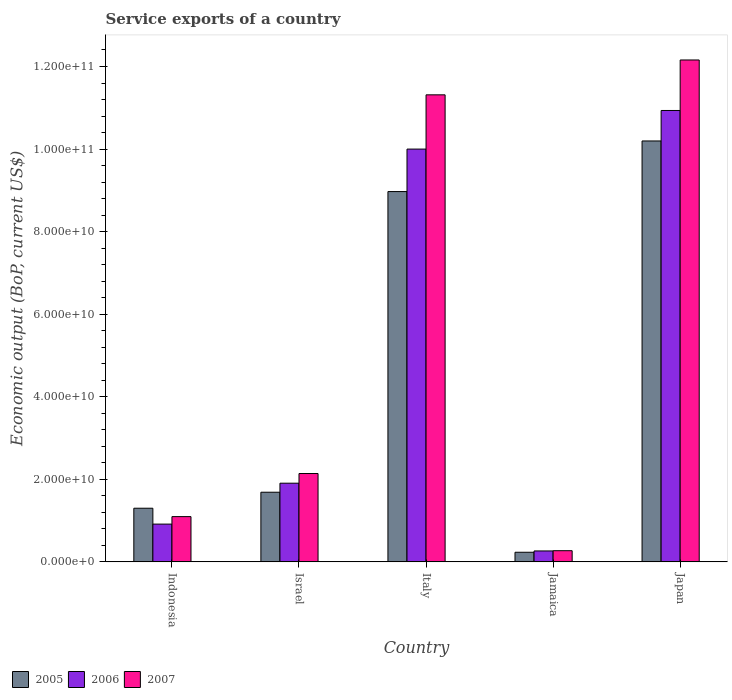How many different coloured bars are there?
Make the answer very short. 3. How many groups of bars are there?
Keep it short and to the point. 5. Are the number of bars per tick equal to the number of legend labels?
Your answer should be very brief. Yes. Are the number of bars on each tick of the X-axis equal?
Offer a very short reply. Yes. How many bars are there on the 4th tick from the right?
Provide a succinct answer. 3. What is the label of the 4th group of bars from the left?
Make the answer very short. Jamaica. What is the service exports in 2005 in Japan?
Offer a terse response. 1.02e+11. Across all countries, what is the maximum service exports in 2005?
Offer a very short reply. 1.02e+11. Across all countries, what is the minimum service exports in 2007?
Give a very brief answer. 2.71e+09. In which country was the service exports in 2006 maximum?
Offer a terse response. Japan. In which country was the service exports in 2006 minimum?
Provide a short and direct response. Jamaica. What is the total service exports in 2005 in the graph?
Ensure brevity in your answer.  2.24e+11. What is the difference between the service exports in 2007 in Israel and that in Italy?
Give a very brief answer. -9.17e+1. What is the difference between the service exports in 2007 in Israel and the service exports in 2006 in Indonesia?
Your response must be concise. 1.23e+1. What is the average service exports in 2006 per country?
Offer a terse response. 4.80e+1. What is the difference between the service exports of/in 2005 and service exports of/in 2006 in Jamaica?
Offer a very short reply. -3.19e+08. What is the ratio of the service exports in 2005 in Italy to that in Japan?
Your answer should be compact. 0.88. Is the service exports in 2006 in Italy less than that in Jamaica?
Ensure brevity in your answer.  No. Is the difference between the service exports in 2005 in Indonesia and Jamaica greater than the difference between the service exports in 2006 in Indonesia and Jamaica?
Offer a terse response. Yes. What is the difference between the highest and the second highest service exports in 2007?
Offer a very short reply. 1.00e+11. What is the difference between the highest and the lowest service exports in 2006?
Offer a very short reply. 1.07e+11. In how many countries, is the service exports in 2005 greater than the average service exports in 2005 taken over all countries?
Give a very brief answer. 2. How many bars are there?
Offer a terse response. 15. How many countries are there in the graph?
Provide a succinct answer. 5. Does the graph contain any zero values?
Give a very brief answer. No. Does the graph contain grids?
Keep it short and to the point. No. Where does the legend appear in the graph?
Your answer should be very brief. Bottom left. How are the legend labels stacked?
Your response must be concise. Horizontal. What is the title of the graph?
Offer a terse response. Service exports of a country. What is the label or title of the Y-axis?
Offer a terse response. Economic output (BoP, current US$). What is the Economic output (BoP, current US$) in 2005 in Indonesia?
Your response must be concise. 1.30e+1. What is the Economic output (BoP, current US$) in 2006 in Indonesia?
Offer a terse response. 9.15e+09. What is the Economic output (BoP, current US$) of 2007 in Indonesia?
Offer a very short reply. 1.10e+1. What is the Economic output (BoP, current US$) of 2005 in Israel?
Ensure brevity in your answer.  1.69e+1. What is the Economic output (BoP, current US$) in 2006 in Israel?
Make the answer very short. 1.91e+1. What is the Economic output (BoP, current US$) in 2007 in Israel?
Provide a short and direct response. 2.14e+1. What is the Economic output (BoP, current US$) of 2005 in Italy?
Provide a succinct answer. 8.97e+1. What is the Economic output (BoP, current US$) of 2006 in Italy?
Provide a succinct answer. 1.00e+11. What is the Economic output (BoP, current US$) in 2007 in Italy?
Offer a very short reply. 1.13e+11. What is the Economic output (BoP, current US$) of 2005 in Jamaica?
Offer a terse response. 2.33e+09. What is the Economic output (BoP, current US$) of 2006 in Jamaica?
Your answer should be compact. 2.65e+09. What is the Economic output (BoP, current US$) of 2007 in Jamaica?
Give a very brief answer. 2.71e+09. What is the Economic output (BoP, current US$) of 2005 in Japan?
Give a very brief answer. 1.02e+11. What is the Economic output (BoP, current US$) in 2006 in Japan?
Offer a terse response. 1.09e+11. What is the Economic output (BoP, current US$) of 2007 in Japan?
Offer a very short reply. 1.22e+11. Across all countries, what is the maximum Economic output (BoP, current US$) in 2005?
Offer a terse response. 1.02e+11. Across all countries, what is the maximum Economic output (BoP, current US$) of 2006?
Your answer should be compact. 1.09e+11. Across all countries, what is the maximum Economic output (BoP, current US$) in 2007?
Your answer should be very brief. 1.22e+11. Across all countries, what is the minimum Economic output (BoP, current US$) of 2005?
Your answer should be very brief. 2.33e+09. Across all countries, what is the minimum Economic output (BoP, current US$) in 2006?
Ensure brevity in your answer.  2.65e+09. Across all countries, what is the minimum Economic output (BoP, current US$) of 2007?
Ensure brevity in your answer.  2.71e+09. What is the total Economic output (BoP, current US$) in 2005 in the graph?
Provide a succinct answer. 2.24e+11. What is the total Economic output (BoP, current US$) of 2006 in the graph?
Your answer should be compact. 2.40e+11. What is the total Economic output (BoP, current US$) of 2007 in the graph?
Your answer should be very brief. 2.70e+11. What is the difference between the Economic output (BoP, current US$) of 2005 in Indonesia and that in Israel?
Make the answer very short. -3.88e+09. What is the difference between the Economic output (BoP, current US$) in 2006 in Indonesia and that in Israel?
Your response must be concise. -9.91e+09. What is the difference between the Economic output (BoP, current US$) of 2007 in Indonesia and that in Israel?
Your response must be concise. -1.04e+1. What is the difference between the Economic output (BoP, current US$) in 2005 in Indonesia and that in Italy?
Your answer should be very brief. -7.67e+1. What is the difference between the Economic output (BoP, current US$) of 2006 in Indonesia and that in Italy?
Offer a terse response. -9.08e+1. What is the difference between the Economic output (BoP, current US$) of 2007 in Indonesia and that in Italy?
Provide a succinct answer. -1.02e+11. What is the difference between the Economic output (BoP, current US$) in 2005 in Indonesia and that in Jamaica?
Make the answer very short. 1.07e+1. What is the difference between the Economic output (BoP, current US$) of 2006 in Indonesia and that in Jamaica?
Give a very brief answer. 6.50e+09. What is the difference between the Economic output (BoP, current US$) of 2007 in Indonesia and that in Jamaica?
Keep it short and to the point. 8.26e+09. What is the difference between the Economic output (BoP, current US$) of 2005 in Indonesia and that in Japan?
Offer a terse response. -8.90e+1. What is the difference between the Economic output (BoP, current US$) of 2006 in Indonesia and that in Japan?
Give a very brief answer. -1.00e+11. What is the difference between the Economic output (BoP, current US$) of 2007 in Indonesia and that in Japan?
Give a very brief answer. -1.11e+11. What is the difference between the Economic output (BoP, current US$) of 2005 in Israel and that in Italy?
Give a very brief answer. -7.28e+1. What is the difference between the Economic output (BoP, current US$) of 2006 in Israel and that in Italy?
Offer a very short reply. -8.09e+1. What is the difference between the Economic output (BoP, current US$) in 2007 in Israel and that in Italy?
Offer a terse response. -9.17e+1. What is the difference between the Economic output (BoP, current US$) of 2005 in Israel and that in Jamaica?
Provide a short and direct response. 1.45e+1. What is the difference between the Economic output (BoP, current US$) of 2006 in Israel and that in Jamaica?
Keep it short and to the point. 1.64e+1. What is the difference between the Economic output (BoP, current US$) in 2007 in Israel and that in Jamaica?
Provide a short and direct response. 1.87e+1. What is the difference between the Economic output (BoP, current US$) in 2005 in Israel and that in Japan?
Offer a terse response. -8.51e+1. What is the difference between the Economic output (BoP, current US$) in 2006 in Israel and that in Japan?
Keep it short and to the point. -9.03e+1. What is the difference between the Economic output (BoP, current US$) in 2007 in Israel and that in Japan?
Your answer should be very brief. -1.00e+11. What is the difference between the Economic output (BoP, current US$) in 2005 in Italy and that in Jamaica?
Keep it short and to the point. 8.74e+1. What is the difference between the Economic output (BoP, current US$) in 2006 in Italy and that in Jamaica?
Give a very brief answer. 9.73e+1. What is the difference between the Economic output (BoP, current US$) of 2007 in Italy and that in Jamaica?
Your answer should be compact. 1.10e+11. What is the difference between the Economic output (BoP, current US$) of 2005 in Italy and that in Japan?
Your answer should be compact. -1.23e+1. What is the difference between the Economic output (BoP, current US$) of 2006 in Italy and that in Japan?
Keep it short and to the point. -9.36e+09. What is the difference between the Economic output (BoP, current US$) of 2007 in Italy and that in Japan?
Offer a terse response. -8.44e+09. What is the difference between the Economic output (BoP, current US$) of 2005 in Jamaica and that in Japan?
Make the answer very short. -9.96e+1. What is the difference between the Economic output (BoP, current US$) of 2006 in Jamaica and that in Japan?
Provide a succinct answer. -1.07e+11. What is the difference between the Economic output (BoP, current US$) of 2007 in Jamaica and that in Japan?
Your answer should be compact. -1.19e+11. What is the difference between the Economic output (BoP, current US$) of 2005 in Indonesia and the Economic output (BoP, current US$) of 2006 in Israel?
Provide a short and direct response. -6.06e+09. What is the difference between the Economic output (BoP, current US$) in 2005 in Indonesia and the Economic output (BoP, current US$) in 2007 in Israel?
Provide a short and direct response. -8.41e+09. What is the difference between the Economic output (BoP, current US$) in 2006 in Indonesia and the Economic output (BoP, current US$) in 2007 in Israel?
Your response must be concise. -1.23e+1. What is the difference between the Economic output (BoP, current US$) of 2005 in Indonesia and the Economic output (BoP, current US$) of 2006 in Italy?
Provide a short and direct response. -8.70e+1. What is the difference between the Economic output (BoP, current US$) of 2005 in Indonesia and the Economic output (BoP, current US$) of 2007 in Italy?
Make the answer very short. -1.00e+11. What is the difference between the Economic output (BoP, current US$) of 2006 in Indonesia and the Economic output (BoP, current US$) of 2007 in Italy?
Offer a very short reply. -1.04e+11. What is the difference between the Economic output (BoP, current US$) of 2005 in Indonesia and the Economic output (BoP, current US$) of 2006 in Jamaica?
Keep it short and to the point. 1.03e+1. What is the difference between the Economic output (BoP, current US$) in 2005 in Indonesia and the Economic output (BoP, current US$) in 2007 in Jamaica?
Provide a succinct answer. 1.03e+1. What is the difference between the Economic output (BoP, current US$) of 2006 in Indonesia and the Economic output (BoP, current US$) of 2007 in Jamaica?
Make the answer very short. 6.44e+09. What is the difference between the Economic output (BoP, current US$) in 2005 in Indonesia and the Economic output (BoP, current US$) in 2006 in Japan?
Make the answer very short. -9.63e+1. What is the difference between the Economic output (BoP, current US$) in 2005 in Indonesia and the Economic output (BoP, current US$) in 2007 in Japan?
Your answer should be very brief. -1.09e+11. What is the difference between the Economic output (BoP, current US$) of 2006 in Indonesia and the Economic output (BoP, current US$) of 2007 in Japan?
Ensure brevity in your answer.  -1.12e+11. What is the difference between the Economic output (BoP, current US$) of 2005 in Israel and the Economic output (BoP, current US$) of 2006 in Italy?
Offer a very short reply. -8.31e+1. What is the difference between the Economic output (BoP, current US$) of 2005 in Israel and the Economic output (BoP, current US$) of 2007 in Italy?
Provide a short and direct response. -9.63e+1. What is the difference between the Economic output (BoP, current US$) of 2006 in Israel and the Economic output (BoP, current US$) of 2007 in Italy?
Your answer should be very brief. -9.41e+1. What is the difference between the Economic output (BoP, current US$) of 2005 in Israel and the Economic output (BoP, current US$) of 2006 in Jamaica?
Make the answer very short. 1.42e+1. What is the difference between the Economic output (BoP, current US$) of 2005 in Israel and the Economic output (BoP, current US$) of 2007 in Jamaica?
Offer a very short reply. 1.42e+1. What is the difference between the Economic output (BoP, current US$) of 2006 in Israel and the Economic output (BoP, current US$) of 2007 in Jamaica?
Your answer should be compact. 1.64e+1. What is the difference between the Economic output (BoP, current US$) in 2005 in Israel and the Economic output (BoP, current US$) in 2006 in Japan?
Make the answer very short. -9.25e+1. What is the difference between the Economic output (BoP, current US$) of 2005 in Israel and the Economic output (BoP, current US$) of 2007 in Japan?
Keep it short and to the point. -1.05e+11. What is the difference between the Economic output (BoP, current US$) of 2006 in Israel and the Economic output (BoP, current US$) of 2007 in Japan?
Provide a short and direct response. -1.03e+11. What is the difference between the Economic output (BoP, current US$) of 2005 in Italy and the Economic output (BoP, current US$) of 2006 in Jamaica?
Your answer should be compact. 8.71e+1. What is the difference between the Economic output (BoP, current US$) of 2005 in Italy and the Economic output (BoP, current US$) of 2007 in Jamaica?
Make the answer very short. 8.70e+1. What is the difference between the Economic output (BoP, current US$) in 2006 in Italy and the Economic output (BoP, current US$) in 2007 in Jamaica?
Your answer should be very brief. 9.73e+1. What is the difference between the Economic output (BoP, current US$) of 2005 in Italy and the Economic output (BoP, current US$) of 2006 in Japan?
Provide a short and direct response. -1.96e+1. What is the difference between the Economic output (BoP, current US$) in 2005 in Italy and the Economic output (BoP, current US$) in 2007 in Japan?
Keep it short and to the point. -3.19e+1. What is the difference between the Economic output (BoP, current US$) in 2006 in Italy and the Economic output (BoP, current US$) in 2007 in Japan?
Provide a short and direct response. -2.16e+1. What is the difference between the Economic output (BoP, current US$) in 2005 in Jamaica and the Economic output (BoP, current US$) in 2006 in Japan?
Make the answer very short. -1.07e+11. What is the difference between the Economic output (BoP, current US$) of 2005 in Jamaica and the Economic output (BoP, current US$) of 2007 in Japan?
Your answer should be compact. -1.19e+11. What is the difference between the Economic output (BoP, current US$) of 2006 in Jamaica and the Economic output (BoP, current US$) of 2007 in Japan?
Offer a terse response. -1.19e+11. What is the average Economic output (BoP, current US$) in 2005 per country?
Provide a succinct answer. 4.48e+1. What is the average Economic output (BoP, current US$) of 2006 per country?
Ensure brevity in your answer.  4.80e+1. What is the average Economic output (BoP, current US$) in 2007 per country?
Provide a succinct answer. 5.40e+1. What is the difference between the Economic output (BoP, current US$) of 2005 and Economic output (BoP, current US$) of 2006 in Indonesia?
Your response must be concise. 3.85e+09. What is the difference between the Economic output (BoP, current US$) in 2005 and Economic output (BoP, current US$) in 2007 in Indonesia?
Your response must be concise. 2.03e+09. What is the difference between the Economic output (BoP, current US$) in 2006 and Economic output (BoP, current US$) in 2007 in Indonesia?
Make the answer very short. -1.82e+09. What is the difference between the Economic output (BoP, current US$) in 2005 and Economic output (BoP, current US$) in 2006 in Israel?
Provide a succinct answer. -2.19e+09. What is the difference between the Economic output (BoP, current US$) in 2005 and Economic output (BoP, current US$) in 2007 in Israel?
Give a very brief answer. -4.53e+09. What is the difference between the Economic output (BoP, current US$) in 2006 and Economic output (BoP, current US$) in 2007 in Israel?
Keep it short and to the point. -2.34e+09. What is the difference between the Economic output (BoP, current US$) of 2005 and Economic output (BoP, current US$) of 2006 in Italy?
Provide a short and direct response. -1.03e+1. What is the difference between the Economic output (BoP, current US$) in 2005 and Economic output (BoP, current US$) in 2007 in Italy?
Your response must be concise. -2.34e+1. What is the difference between the Economic output (BoP, current US$) of 2006 and Economic output (BoP, current US$) of 2007 in Italy?
Offer a terse response. -1.31e+1. What is the difference between the Economic output (BoP, current US$) in 2005 and Economic output (BoP, current US$) in 2006 in Jamaica?
Offer a terse response. -3.19e+08. What is the difference between the Economic output (BoP, current US$) in 2005 and Economic output (BoP, current US$) in 2007 in Jamaica?
Your answer should be very brief. -3.77e+08. What is the difference between the Economic output (BoP, current US$) of 2006 and Economic output (BoP, current US$) of 2007 in Jamaica?
Offer a terse response. -5.79e+07. What is the difference between the Economic output (BoP, current US$) in 2005 and Economic output (BoP, current US$) in 2006 in Japan?
Keep it short and to the point. -7.38e+09. What is the difference between the Economic output (BoP, current US$) of 2005 and Economic output (BoP, current US$) of 2007 in Japan?
Your response must be concise. -1.96e+1. What is the difference between the Economic output (BoP, current US$) of 2006 and Economic output (BoP, current US$) of 2007 in Japan?
Your answer should be very brief. -1.22e+1. What is the ratio of the Economic output (BoP, current US$) in 2005 in Indonesia to that in Israel?
Make the answer very short. 0.77. What is the ratio of the Economic output (BoP, current US$) in 2006 in Indonesia to that in Israel?
Your answer should be very brief. 0.48. What is the ratio of the Economic output (BoP, current US$) in 2007 in Indonesia to that in Israel?
Offer a very short reply. 0.51. What is the ratio of the Economic output (BoP, current US$) of 2005 in Indonesia to that in Italy?
Ensure brevity in your answer.  0.14. What is the ratio of the Economic output (BoP, current US$) in 2006 in Indonesia to that in Italy?
Your answer should be very brief. 0.09. What is the ratio of the Economic output (BoP, current US$) in 2007 in Indonesia to that in Italy?
Your answer should be compact. 0.1. What is the ratio of the Economic output (BoP, current US$) in 2005 in Indonesia to that in Jamaica?
Give a very brief answer. 5.58. What is the ratio of the Economic output (BoP, current US$) of 2006 in Indonesia to that in Jamaica?
Your answer should be compact. 3.45. What is the ratio of the Economic output (BoP, current US$) in 2007 in Indonesia to that in Jamaica?
Ensure brevity in your answer.  4.05. What is the ratio of the Economic output (BoP, current US$) of 2005 in Indonesia to that in Japan?
Your response must be concise. 0.13. What is the ratio of the Economic output (BoP, current US$) in 2006 in Indonesia to that in Japan?
Make the answer very short. 0.08. What is the ratio of the Economic output (BoP, current US$) of 2007 in Indonesia to that in Japan?
Your answer should be compact. 0.09. What is the ratio of the Economic output (BoP, current US$) in 2005 in Israel to that in Italy?
Give a very brief answer. 0.19. What is the ratio of the Economic output (BoP, current US$) in 2006 in Israel to that in Italy?
Offer a terse response. 0.19. What is the ratio of the Economic output (BoP, current US$) in 2007 in Israel to that in Italy?
Offer a terse response. 0.19. What is the ratio of the Economic output (BoP, current US$) of 2005 in Israel to that in Jamaica?
Ensure brevity in your answer.  7.24. What is the ratio of the Economic output (BoP, current US$) of 2006 in Israel to that in Jamaica?
Ensure brevity in your answer.  7.2. What is the ratio of the Economic output (BoP, current US$) in 2007 in Israel to that in Jamaica?
Ensure brevity in your answer.  7.91. What is the ratio of the Economic output (BoP, current US$) of 2005 in Israel to that in Japan?
Give a very brief answer. 0.17. What is the ratio of the Economic output (BoP, current US$) of 2006 in Israel to that in Japan?
Keep it short and to the point. 0.17. What is the ratio of the Economic output (BoP, current US$) in 2007 in Israel to that in Japan?
Provide a succinct answer. 0.18. What is the ratio of the Economic output (BoP, current US$) of 2005 in Italy to that in Jamaica?
Make the answer very short. 38.5. What is the ratio of the Economic output (BoP, current US$) of 2006 in Italy to that in Jamaica?
Offer a very short reply. 37.75. What is the ratio of the Economic output (BoP, current US$) of 2007 in Italy to that in Jamaica?
Your answer should be very brief. 41.8. What is the ratio of the Economic output (BoP, current US$) of 2005 in Italy to that in Japan?
Your response must be concise. 0.88. What is the ratio of the Economic output (BoP, current US$) of 2006 in Italy to that in Japan?
Make the answer very short. 0.91. What is the ratio of the Economic output (BoP, current US$) in 2007 in Italy to that in Japan?
Provide a short and direct response. 0.93. What is the ratio of the Economic output (BoP, current US$) of 2005 in Jamaica to that in Japan?
Your answer should be compact. 0.02. What is the ratio of the Economic output (BoP, current US$) of 2006 in Jamaica to that in Japan?
Provide a short and direct response. 0.02. What is the ratio of the Economic output (BoP, current US$) in 2007 in Jamaica to that in Japan?
Offer a terse response. 0.02. What is the difference between the highest and the second highest Economic output (BoP, current US$) of 2005?
Ensure brevity in your answer.  1.23e+1. What is the difference between the highest and the second highest Economic output (BoP, current US$) in 2006?
Ensure brevity in your answer.  9.36e+09. What is the difference between the highest and the second highest Economic output (BoP, current US$) of 2007?
Offer a very short reply. 8.44e+09. What is the difference between the highest and the lowest Economic output (BoP, current US$) of 2005?
Offer a terse response. 9.96e+1. What is the difference between the highest and the lowest Economic output (BoP, current US$) of 2006?
Make the answer very short. 1.07e+11. What is the difference between the highest and the lowest Economic output (BoP, current US$) in 2007?
Give a very brief answer. 1.19e+11. 